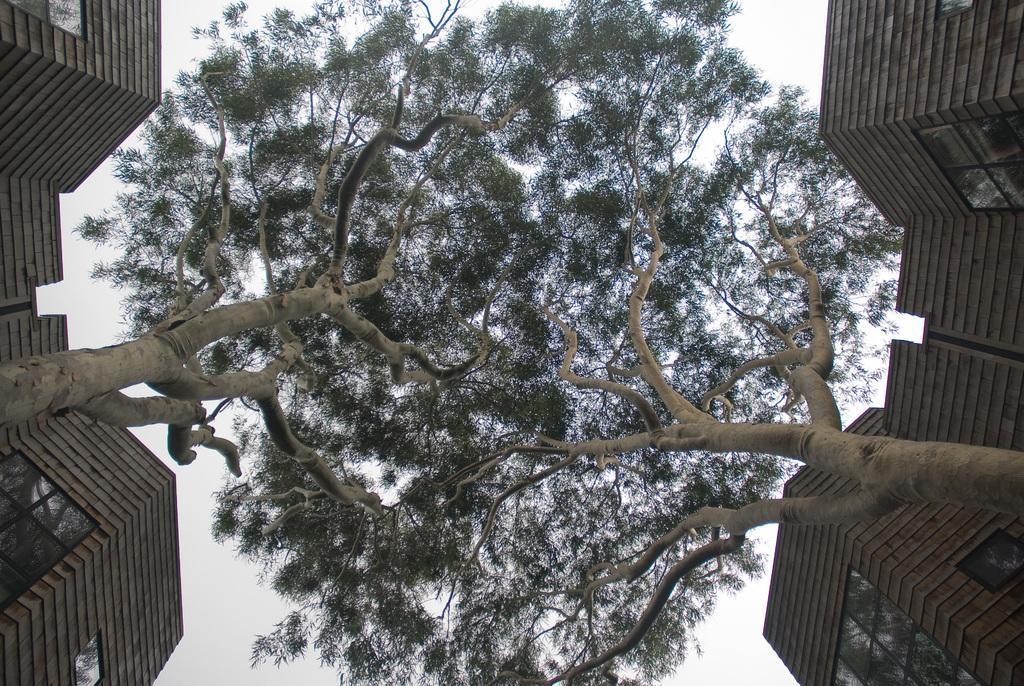In one or two sentences, can you explain what this image depicts? On the left and right side of the image we can see few buildings and we can find few trees. 